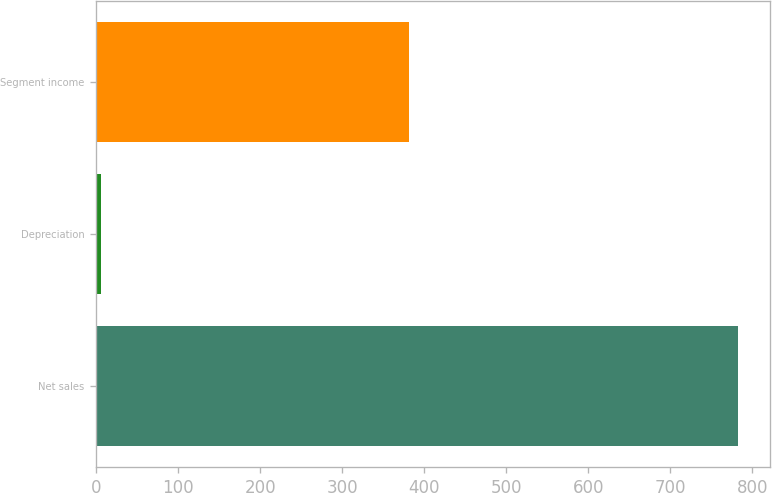<chart> <loc_0><loc_0><loc_500><loc_500><bar_chart><fcel>Net sales<fcel>Depreciation<fcel>Segment income<nl><fcel>783<fcel>6<fcel>382<nl></chart> 